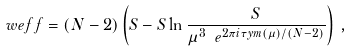Convert formula to latex. <formula><loc_0><loc_0><loc_500><loc_500>\ w e f f = ( N - 2 ) \left ( S - S \ln \frac { S } { \mu ^ { 3 } \ e ^ { 2 \pi i \tau y m ( \mu ) / ( N - 2 ) } } \right ) \, ,</formula> 